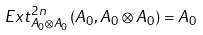<formula> <loc_0><loc_0><loc_500><loc_500>E x t _ { A _ { 0 } \otimes A _ { 0 } } ^ { 2 n } ( A _ { 0 } , A _ { 0 } \otimes A _ { 0 } ) = A _ { 0 }</formula> 